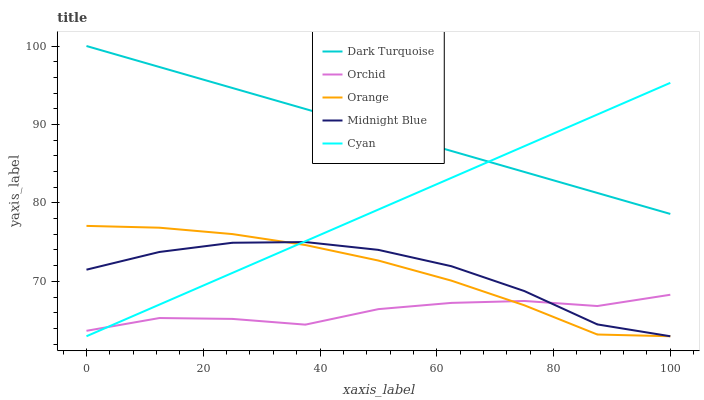Does Orchid have the minimum area under the curve?
Answer yes or no. Yes. Does Dark Turquoise have the maximum area under the curve?
Answer yes or no. Yes. Does Cyan have the minimum area under the curve?
Answer yes or no. No. Does Cyan have the maximum area under the curve?
Answer yes or no. No. Is Dark Turquoise the smoothest?
Answer yes or no. Yes. Is Orchid the roughest?
Answer yes or no. Yes. Is Cyan the smoothest?
Answer yes or no. No. Is Cyan the roughest?
Answer yes or no. No. Does Dark Turquoise have the lowest value?
Answer yes or no. No. Does Dark Turquoise have the highest value?
Answer yes or no. Yes. Does Cyan have the highest value?
Answer yes or no. No. Is Midnight Blue less than Dark Turquoise?
Answer yes or no. Yes. Is Dark Turquoise greater than Midnight Blue?
Answer yes or no. Yes. Does Orchid intersect Orange?
Answer yes or no. Yes. Is Orchid less than Orange?
Answer yes or no. No. Is Orchid greater than Orange?
Answer yes or no. No. Does Midnight Blue intersect Dark Turquoise?
Answer yes or no. No. 